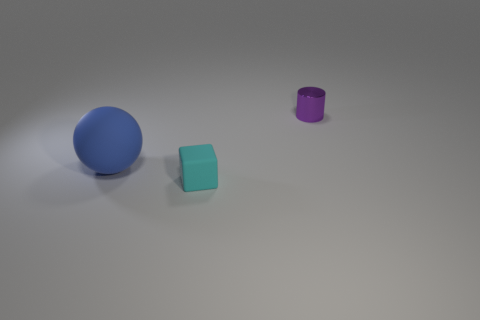How many blue matte objects are in front of the tiny thing in front of the small purple metallic cylinder? There is one blue matte sphere in front of the tiny teal cube, which is in front of the small purple metallic cylinder. 